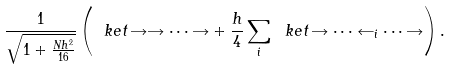Convert formula to latex. <formula><loc_0><loc_0><loc_500><loc_500>\frac { 1 } { \sqrt { 1 + \frac { N h ^ { 2 } } { 1 6 } } } \left ( \ k e t { \, \rightarrow \rightarrow \dots \rightarrow } + \frac { h } { 4 } \sum _ { i } \ k e t { \, \rightarrow \dots \leftarrow _ { i } \dots \rightarrow } \right ) .</formula> 